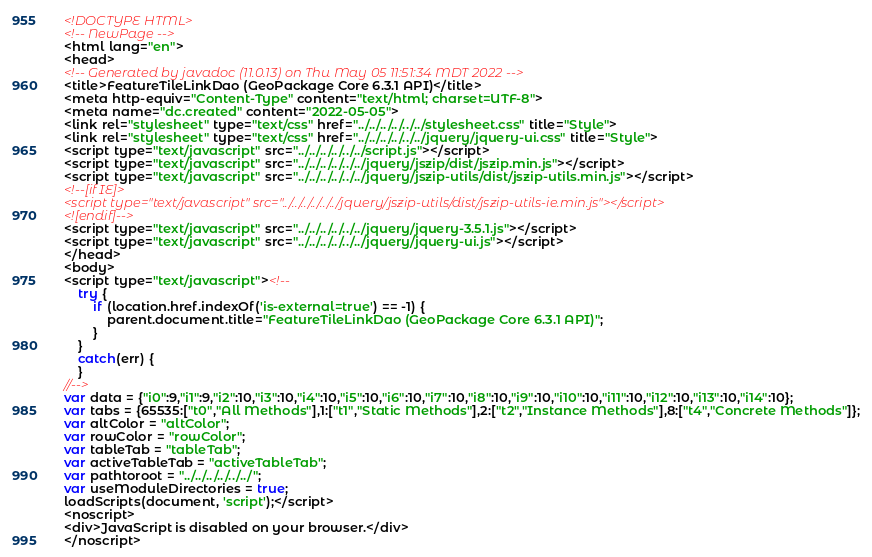<code> <loc_0><loc_0><loc_500><loc_500><_HTML_><!DOCTYPE HTML>
<!-- NewPage -->
<html lang="en">
<head>
<!-- Generated by javadoc (11.0.13) on Thu May 05 11:51:34 MDT 2022 -->
<title>FeatureTileLinkDao (GeoPackage Core 6.3.1 API)</title>
<meta http-equiv="Content-Type" content="text/html; charset=UTF-8">
<meta name="dc.created" content="2022-05-05">
<link rel="stylesheet" type="text/css" href="../../../../../../stylesheet.css" title="Style">
<link rel="stylesheet" type="text/css" href="../../../../../../jquery/jquery-ui.css" title="Style">
<script type="text/javascript" src="../../../../../../script.js"></script>
<script type="text/javascript" src="../../../../../../jquery/jszip/dist/jszip.min.js"></script>
<script type="text/javascript" src="../../../../../../jquery/jszip-utils/dist/jszip-utils.min.js"></script>
<!--[if IE]>
<script type="text/javascript" src="../../../../../../jquery/jszip-utils/dist/jszip-utils-ie.min.js"></script>
<![endif]-->
<script type="text/javascript" src="../../../../../../jquery/jquery-3.5.1.js"></script>
<script type="text/javascript" src="../../../../../../jquery/jquery-ui.js"></script>
</head>
<body>
<script type="text/javascript"><!--
    try {
        if (location.href.indexOf('is-external=true') == -1) {
            parent.document.title="FeatureTileLinkDao (GeoPackage Core 6.3.1 API)";
        }
    }
    catch(err) {
    }
//-->
var data = {"i0":9,"i1":9,"i2":10,"i3":10,"i4":10,"i5":10,"i6":10,"i7":10,"i8":10,"i9":10,"i10":10,"i11":10,"i12":10,"i13":10,"i14":10};
var tabs = {65535:["t0","All Methods"],1:["t1","Static Methods"],2:["t2","Instance Methods"],8:["t4","Concrete Methods"]};
var altColor = "altColor";
var rowColor = "rowColor";
var tableTab = "tableTab";
var activeTableTab = "activeTableTab";
var pathtoroot = "../../../../../../";
var useModuleDirectories = true;
loadScripts(document, 'script');</script>
<noscript>
<div>JavaScript is disabled on your browser.</div>
</noscript></code> 